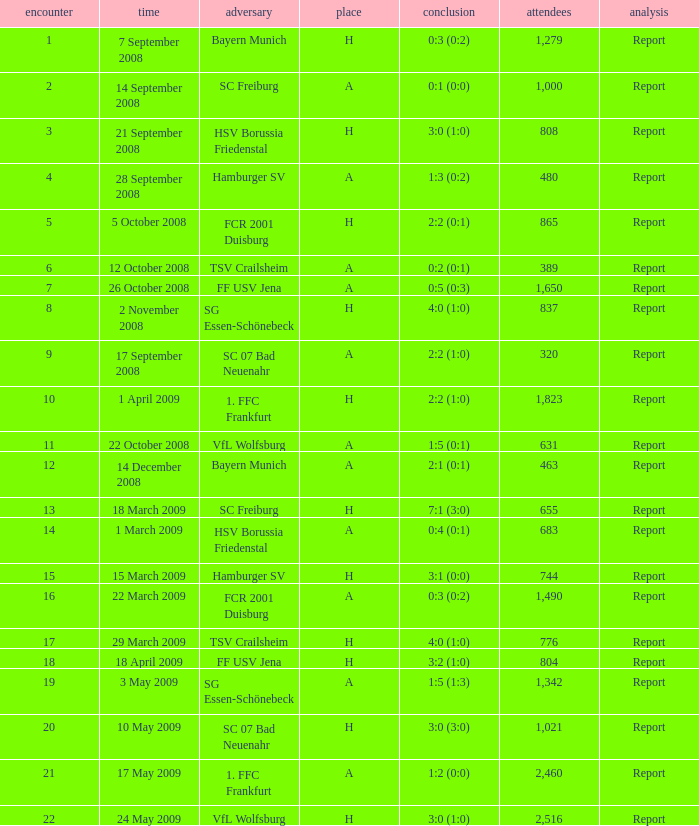Which match did FCR 2001 Duisburg participate as the opponent? 21.0. 